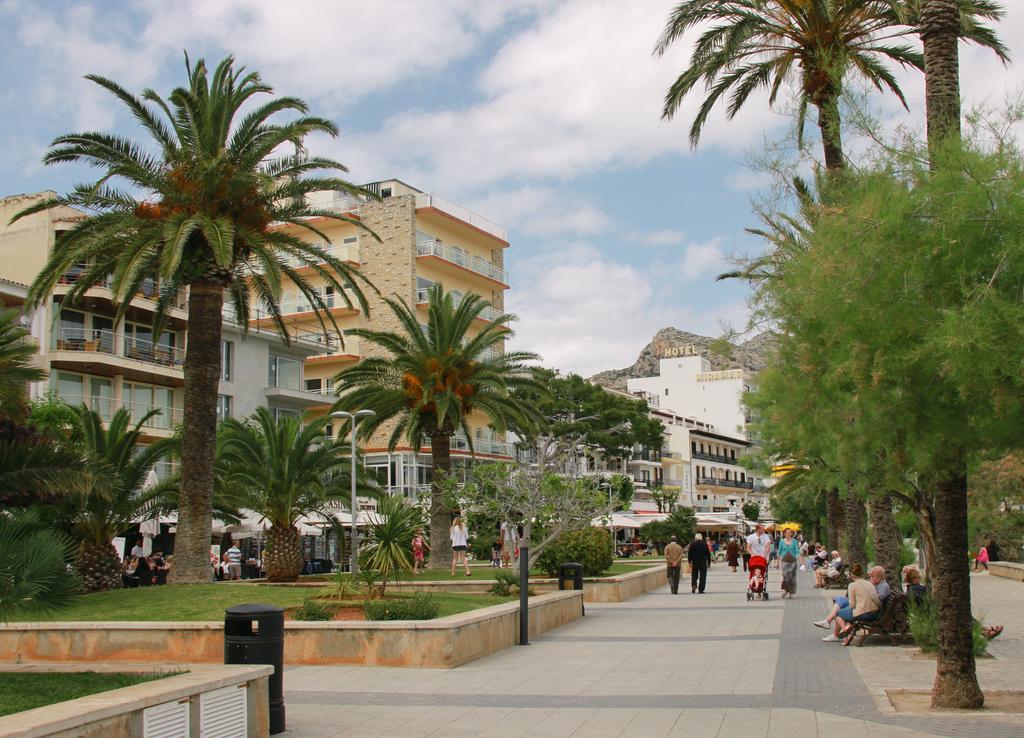Describe this image in one or two sentences. In this image I can see people where few are sitting and rest all are standing. I can also see number of trees, buildings, clouds and the sky. I can also see something is written over there and here I can see a black colour object. 